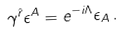<formula> <loc_0><loc_0><loc_500><loc_500>\gamma ^ { \hat { r } } \epsilon ^ { A } = e ^ { - i \Lambda } \epsilon _ { A } \, .</formula> 